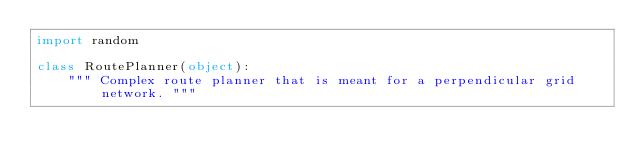Convert code to text. <code><loc_0><loc_0><loc_500><loc_500><_Python_>import random

class RoutePlanner(object):
    """ Complex route planner that is meant for a perpendicular grid network. """
</code> 